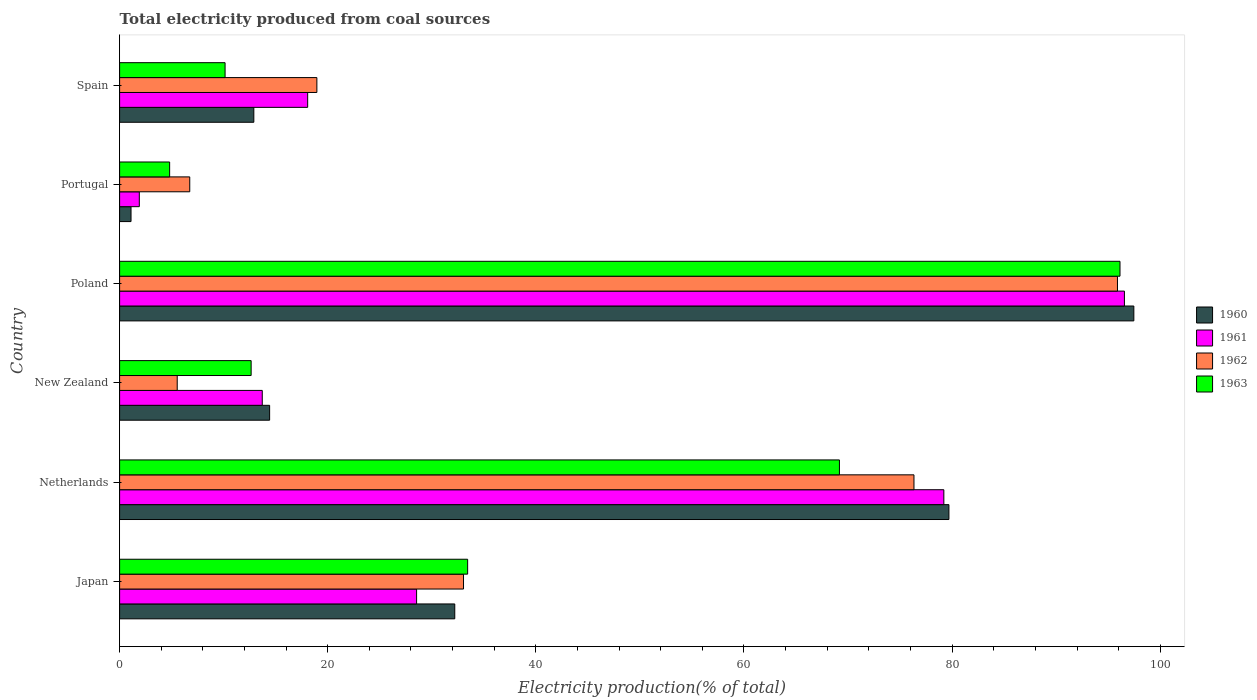How many different coloured bars are there?
Make the answer very short. 4. Are the number of bars on each tick of the Y-axis equal?
Provide a succinct answer. Yes. How many bars are there on the 2nd tick from the bottom?
Ensure brevity in your answer.  4. What is the label of the 4th group of bars from the top?
Ensure brevity in your answer.  New Zealand. In how many cases, is the number of bars for a given country not equal to the number of legend labels?
Your answer should be very brief. 0. What is the total electricity produced in 1962 in New Zealand?
Provide a succinct answer. 5.54. Across all countries, what is the maximum total electricity produced in 1960?
Your response must be concise. 97.46. Across all countries, what is the minimum total electricity produced in 1963?
Your answer should be very brief. 4.81. In which country was the total electricity produced in 1962 maximum?
Your answer should be compact. Poland. In which country was the total electricity produced in 1963 minimum?
Ensure brevity in your answer.  Portugal. What is the total total electricity produced in 1961 in the graph?
Provide a succinct answer. 237.98. What is the difference between the total electricity produced in 1962 in New Zealand and that in Poland?
Offer a very short reply. -90.35. What is the difference between the total electricity produced in 1963 in Japan and the total electricity produced in 1962 in Portugal?
Give a very brief answer. 26.7. What is the average total electricity produced in 1961 per country?
Provide a succinct answer. 39.66. What is the difference between the total electricity produced in 1960 and total electricity produced in 1961 in Poland?
Make the answer very short. 0.91. What is the ratio of the total electricity produced in 1963 in Japan to that in Netherlands?
Make the answer very short. 0.48. Is the total electricity produced in 1963 in Poland less than that in Portugal?
Keep it short and to the point. No. Is the difference between the total electricity produced in 1960 in Japan and Portugal greater than the difference between the total electricity produced in 1961 in Japan and Portugal?
Provide a succinct answer. Yes. What is the difference between the highest and the second highest total electricity produced in 1963?
Your answer should be compact. 26.96. What is the difference between the highest and the lowest total electricity produced in 1961?
Give a very brief answer. 94.66. In how many countries, is the total electricity produced in 1961 greater than the average total electricity produced in 1961 taken over all countries?
Offer a terse response. 2. Is the sum of the total electricity produced in 1962 in Poland and Spain greater than the maximum total electricity produced in 1963 across all countries?
Provide a succinct answer. Yes. How many bars are there?
Offer a very short reply. 24. What is the difference between two consecutive major ticks on the X-axis?
Offer a terse response. 20. Are the values on the major ticks of X-axis written in scientific E-notation?
Keep it short and to the point. No. Does the graph contain any zero values?
Give a very brief answer. No. Does the graph contain grids?
Ensure brevity in your answer.  No. How many legend labels are there?
Offer a very short reply. 4. How are the legend labels stacked?
Your answer should be very brief. Vertical. What is the title of the graph?
Provide a short and direct response. Total electricity produced from coal sources. Does "1997" appear as one of the legend labels in the graph?
Offer a very short reply. No. What is the label or title of the X-axis?
Provide a succinct answer. Electricity production(% of total). What is the label or title of the Y-axis?
Give a very brief answer. Country. What is the Electricity production(% of total) of 1960 in Japan?
Make the answer very short. 32.21. What is the Electricity production(% of total) of 1961 in Japan?
Provide a short and direct response. 28.54. What is the Electricity production(% of total) in 1962 in Japan?
Offer a terse response. 33.05. What is the Electricity production(% of total) in 1963 in Japan?
Your answer should be compact. 33.44. What is the Electricity production(% of total) in 1960 in Netherlands?
Provide a short and direct response. 79.69. What is the Electricity production(% of total) of 1961 in Netherlands?
Provide a succinct answer. 79.2. What is the Electricity production(% of total) in 1962 in Netherlands?
Make the answer very short. 76.33. What is the Electricity production(% of total) in 1963 in Netherlands?
Provide a short and direct response. 69.17. What is the Electricity production(% of total) in 1960 in New Zealand?
Make the answer very short. 14.42. What is the Electricity production(% of total) in 1961 in New Zealand?
Offer a very short reply. 13.71. What is the Electricity production(% of total) of 1962 in New Zealand?
Your response must be concise. 5.54. What is the Electricity production(% of total) of 1963 in New Zealand?
Provide a short and direct response. 12.64. What is the Electricity production(% of total) in 1960 in Poland?
Offer a very short reply. 97.46. What is the Electricity production(% of total) in 1961 in Poland?
Keep it short and to the point. 96.56. What is the Electricity production(% of total) of 1962 in Poland?
Your answer should be very brief. 95.89. What is the Electricity production(% of total) in 1963 in Poland?
Give a very brief answer. 96.13. What is the Electricity production(% of total) of 1960 in Portugal?
Offer a terse response. 1.1. What is the Electricity production(% of total) in 1961 in Portugal?
Ensure brevity in your answer.  1.89. What is the Electricity production(% of total) in 1962 in Portugal?
Provide a succinct answer. 6.74. What is the Electricity production(% of total) of 1963 in Portugal?
Provide a succinct answer. 4.81. What is the Electricity production(% of total) of 1960 in Spain?
Offer a terse response. 12.9. What is the Electricity production(% of total) of 1961 in Spain?
Make the answer very short. 18.07. What is the Electricity production(% of total) of 1962 in Spain?
Make the answer very short. 18.96. What is the Electricity production(% of total) of 1963 in Spain?
Your answer should be very brief. 10.14. Across all countries, what is the maximum Electricity production(% of total) in 1960?
Your response must be concise. 97.46. Across all countries, what is the maximum Electricity production(% of total) in 1961?
Make the answer very short. 96.56. Across all countries, what is the maximum Electricity production(% of total) in 1962?
Your answer should be compact. 95.89. Across all countries, what is the maximum Electricity production(% of total) in 1963?
Offer a terse response. 96.13. Across all countries, what is the minimum Electricity production(% of total) in 1960?
Ensure brevity in your answer.  1.1. Across all countries, what is the minimum Electricity production(% of total) of 1961?
Provide a short and direct response. 1.89. Across all countries, what is the minimum Electricity production(% of total) of 1962?
Your response must be concise. 5.54. Across all countries, what is the minimum Electricity production(% of total) in 1963?
Your answer should be very brief. 4.81. What is the total Electricity production(% of total) of 1960 in the graph?
Keep it short and to the point. 237.78. What is the total Electricity production(% of total) of 1961 in the graph?
Make the answer very short. 237.98. What is the total Electricity production(% of total) of 1962 in the graph?
Offer a terse response. 236.5. What is the total Electricity production(% of total) in 1963 in the graph?
Your answer should be compact. 226.33. What is the difference between the Electricity production(% of total) in 1960 in Japan and that in Netherlands?
Keep it short and to the point. -47.48. What is the difference between the Electricity production(% of total) of 1961 in Japan and that in Netherlands?
Provide a succinct answer. -50.67. What is the difference between the Electricity production(% of total) in 1962 in Japan and that in Netherlands?
Your response must be concise. -43.28. What is the difference between the Electricity production(% of total) in 1963 in Japan and that in Netherlands?
Make the answer very short. -35.73. What is the difference between the Electricity production(% of total) of 1960 in Japan and that in New Zealand?
Your answer should be very brief. 17.79. What is the difference between the Electricity production(% of total) in 1961 in Japan and that in New Zealand?
Offer a very short reply. 14.83. What is the difference between the Electricity production(% of total) of 1962 in Japan and that in New Zealand?
Provide a short and direct response. 27.51. What is the difference between the Electricity production(% of total) in 1963 in Japan and that in New Zealand?
Give a very brief answer. 20.8. What is the difference between the Electricity production(% of total) in 1960 in Japan and that in Poland?
Your answer should be very brief. -65.25. What is the difference between the Electricity production(% of total) in 1961 in Japan and that in Poland?
Keep it short and to the point. -68.02. What is the difference between the Electricity production(% of total) of 1962 in Japan and that in Poland?
Your answer should be very brief. -62.84. What is the difference between the Electricity production(% of total) of 1963 in Japan and that in Poland?
Keep it short and to the point. -62.69. What is the difference between the Electricity production(% of total) of 1960 in Japan and that in Portugal?
Keep it short and to the point. 31.11. What is the difference between the Electricity production(% of total) of 1961 in Japan and that in Portugal?
Offer a terse response. 26.64. What is the difference between the Electricity production(% of total) in 1962 in Japan and that in Portugal?
Your response must be concise. 26.31. What is the difference between the Electricity production(% of total) in 1963 in Japan and that in Portugal?
Your answer should be very brief. 28.63. What is the difference between the Electricity production(% of total) in 1960 in Japan and that in Spain?
Provide a short and direct response. 19.31. What is the difference between the Electricity production(% of total) in 1961 in Japan and that in Spain?
Keep it short and to the point. 10.47. What is the difference between the Electricity production(% of total) in 1962 in Japan and that in Spain?
Your response must be concise. 14.09. What is the difference between the Electricity production(% of total) of 1963 in Japan and that in Spain?
Your answer should be very brief. 23.31. What is the difference between the Electricity production(% of total) of 1960 in Netherlands and that in New Zealand?
Keep it short and to the point. 65.28. What is the difference between the Electricity production(% of total) in 1961 in Netherlands and that in New Zealand?
Ensure brevity in your answer.  65.5. What is the difference between the Electricity production(% of total) in 1962 in Netherlands and that in New Zealand?
Make the answer very short. 70.8. What is the difference between the Electricity production(% of total) in 1963 in Netherlands and that in New Zealand?
Your answer should be very brief. 56.53. What is the difference between the Electricity production(% of total) in 1960 in Netherlands and that in Poland?
Ensure brevity in your answer.  -17.77. What is the difference between the Electricity production(% of total) of 1961 in Netherlands and that in Poland?
Give a very brief answer. -17.35. What is the difference between the Electricity production(% of total) of 1962 in Netherlands and that in Poland?
Give a very brief answer. -19.56. What is the difference between the Electricity production(% of total) of 1963 in Netherlands and that in Poland?
Make the answer very short. -26.96. What is the difference between the Electricity production(% of total) of 1960 in Netherlands and that in Portugal?
Your answer should be very brief. 78.59. What is the difference between the Electricity production(% of total) of 1961 in Netherlands and that in Portugal?
Provide a succinct answer. 77.31. What is the difference between the Electricity production(% of total) in 1962 in Netherlands and that in Portugal?
Ensure brevity in your answer.  69.59. What is the difference between the Electricity production(% of total) of 1963 in Netherlands and that in Portugal?
Your response must be concise. 64.36. What is the difference between the Electricity production(% of total) in 1960 in Netherlands and that in Spain?
Make the answer very short. 66.79. What is the difference between the Electricity production(% of total) of 1961 in Netherlands and that in Spain?
Keep it short and to the point. 61.13. What is the difference between the Electricity production(% of total) in 1962 in Netherlands and that in Spain?
Provide a succinct answer. 57.38. What is the difference between the Electricity production(% of total) of 1963 in Netherlands and that in Spain?
Your answer should be very brief. 59.04. What is the difference between the Electricity production(% of total) in 1960 in New Zealand and that in Poland?
Provide a succinct answer. -83.05. What is the difference between the Electricity production(% of total) in 1961 in New Zealand and that in Poland?
Offer a terse response. -82.85. What is the difference between the Electricity production(% of total) of 1962 in New Zealand and that in Poland?
Your answer should be very brief. -90.35. What is the difference between the Electricity production(% of total) in 1963 in New Zealand and that in Poland?
Give a very brief answer. -83.49. What is the difference between the Electricity production(% of total) in 1960 in New Zealand and that in Portugal?
Provide a short and direct response. 13.32. What is the difference between the Electricity production(% of total) in 1961 in New Zealand and that in Portugal?
Offer a terse response. 11.81. What is the difference between the Electricity production(% of total) of 1962 in New Zealand and that in Portugal?
Make the answer very short. -1.2. What is the difference between the Electricity production(% of total) of 1963 in New Zealand and that in Portugal?
Keep it short and to the point. 7.83. What is the difference between the Electricity production(% of total) of 1960 in New Zealand and that in Spain?
Offer a very short reply. 1.52. What is the difference between the Electricity production(% of total) of 1961 in New Zealand and that in Spain?
Your answer should be very brief. -4.36. What is the difference between the Electricity production(% of total) in 1962 in New Zealand and that in Spain?
Offer a very short reply. -13.42. What is the difference between the Electricity production(% of total) in 1963 in New Zealand and that in Spain?
Keep it short and to the point. 2.5. What is the difference between the Electricity production(% of total) of 1960 in Poland and that in Portugal?
Your response must be concise. 96.36. What is the difference between the Electricity production(% of total) in 1961 in Poland and that in Portugal?
Give a very brief answer. 94.66. What is the difference between the Electricity production(% of total) of 1962 in Poland and that in Portugal?
Provide a succinct answer. 89.15. What is the difference between the Electricity production(% of total) of 1963 in Poland and that in Portugal?
Provide a short and direct response. 91.32. What is the difference between the Electricity production(% of total) of 1960 in Poland and that in Spain?
Your response must be concise. 84.56. What is the difference between the Electricity production(% of total) of 1961 in Poland and that in Spain?
Provide a short and direct response. 78.49. What is the difference between the Electricity production(% of total) of 1962 in Poland and that in Spain?
Your response must be concise. 76.93. What is the difference between the Electricity production(% of total) in 1963 in Poland and that in Spain?
Provide a succinct answer. 86. What is the difference between the Electricity production(% of total) in 1960 in Portugal and that in Spain?
Offer a terse response. -11.8. What is the difference between the Electricity production(% of total) of 1961 in Portugal and that in Spain?
Offer a very short reply. -16.18. What is the difference between the Electricity production(% of total) of 1962 in Portugal and that in Spain?
Your answer should be very brief. -12.22. What is the difference between the Electricity production(% of total) of 1963 in Portugal and that in Spain?
Keep it short and to the point. -5.33. What is the difference between the Electricity production(% of total) in 1960 in Japan and the Electricity production(% of total) in 1961 in Netherlands?
Make the answer very short. -47. What is the difference between the Electricity production(% of total) in 1960 in Japan and the Electricity production(% of total) in 1962 in Netherlands?
Provide a short and direct response. -44.13. What is the difference between the Electricity production(% of total) of 1960 in Japan and the Electricity production(% of total) of 1963 in Netherlands?
Keep it short and to the point. -36.96. What is the difference between the Electricity production(% of total) in 1961 in Japan and the Electricity production(% of total) in 1962 in Netherlands?
Ensure brevity in your answer.  -47.79. What is the difference between the Electricity production(% of total) in 1961 in Japan and the Electricity production(% of total) in 1963 in Netherlands?
Give a very brief answer. -40.63. What is the difference between the Electricity production(% of total) of 1962 in Japan and the Electricity production(% of total) of 1963 in Netherlands?
Keep it short and to the point. -36.12. What is the difference between the Electricity production(% of total) in 1960 in Japan and the Electricity production(% of total) in 1961 in New Zealand?
Ensure brevity in your answer.  18.5. What is the difference between the Electricity production(% of total) in 1960 in Japan and the Electricity production(% of total) in 1962 in New Zealand?
Keep it short and to the point. 26.67. What is the difference between the Electricity production(% of total) in 1960 in Japan and the Electricity production(% of total) in 1963 in New Zealand?
Provide a short and direct response. 19.57. What is the difference between the Electricity production(% of total) of 1961 in Japan and the Electricity production(% of total) of 1962 in New Zealand?
Make the answer very short. 23. What is the difference between the Electricity production(% of total) in 1961 in Japan and the Electricity production(% of total) in 1963 in New Zealand?
Ensure brevity in your answer.  15.9. What is the difference between the Electricity production(% of total) of 1962 in Japan and the Electricity production(% of total) of 1963 in New Zealand?
Your answer should be compact. 20.41. What is the difference between the Electricity production(% of total) of 1960 in Japan and the Electricity production(% of total) of 1961 in Poland?
Offer a very short reply. -64.35. What is the difference between the Electricity production(% of total) in 1960 in Japan and the Electricity production(% of total) in 1962 in Poland?
Provide a succinct answer. -63.68. What is the difference between the Electricity production(% of total) of 1960 in Japan and the Electricity production(% of total) of 1963 in Poland?
Provide a succinct answer. -63.92. What is the difference between the Electricity production(% of total) of 1961 in Japan and the Electricity production(% of total) of 1962 in Poland?
Offer a very short reply. -67.35. What is the difference between the Electricity production(% of total) in 1961 in Japan and the Electricity production(% of total) in 1963 in Poland?
Keep it short and to the point. -67.59. What is the difference between the Electricity production(% of total) in 1962 in Japan and the Electricity production(% of total) in 1963 in Poland?
Ensure brevity in your answer.  -63.08. What is the difference between the Electricity production(% of total) of 1960 in Japan and the Electricity production(% of total) of 1961 in Portugal?
Provide a short and direct response. 30.31. What is the difference between the Electricity production(% of total) in 1960 in Japan and the Electricity production(% of total) in 1962 in Portugal?
Provide a succinct answer. 25.47. What is the difference between the Electricity production(% of total) in 1960 in Japan and the Electricity production(% of total) in 1963 in Portugal?
Offer a very short reply. 27.4. What is the difference between the Electricity production(% of total) of 1961 in Japan and the Electricity production(% of total) of 1962 in Portugal?
Your answer should be very brief. 21.8. What is the difference between the Electricity production(% of total) of 1961 in Japan and the Electricity production(% of total) of 1963 in Portugal?
Give a very brief answer. 23.73. What is the difference between the Electricity production(% of total) in 1962 in Japan and the Electricity production(% of total) in 1963 in Portugal?
Keep it short and to the point. 28.24. What is the difference between the Electricity production(% of total) in 1960 in Japan and the Electricity production(% of total) in 1961 in Spain?
Offer a terse response. 14.14. What is the difference between the Electricity production(% of total) of 1960 in Japan and the Electricity production(% of total) of 1962 in Spain?
Your response must be concise. 13.25. What is the difference between the Electricity production(% of total) in 1960 in Japan and the Electricity production(% of total) in 1963 in Spain?
Offer a terse response. 22.07. What is the difference between the Electricity production(% of total) of 1961 in Japan and the Electricity production(% of total) of 1962 in Spain?
Keep it short and to the point. 9.58. What is the difference between the Electricity production(% of total) in 1961 in Japan and the Electricity production(% of total) in 1963 in Spain?
Provide a short and direct response. 18.4. What is the difference between the Electricity production(% of total) of 1962 in Japan and the Electricity production(% of total) of 1963 in Spain?
Your answer should be very brief. 22.91. What is the difference between the Electricity production(% of total) in 1960 in Netherlands and the Electricity production(% of total) in 1961 in New Zealand?
Give a very brief answer. 65.98. What is the difference between the Electricity production(% of total) of 1960 in Netherlands and the Electricity production(% of total) of 1962 in New Zealand?
Your answer should be very brief. 74.16. What is the difference between the Electricity production(% of total) in 1960 in Netherlands and the Electricity production(% of total) in 1963 in New Zealand?
Keep it short and to the point. 67.05. What is the difference between the Electricity production(% of total) in 1961 in Netherlands and the Electricity production(% of total) in 1962 in New Zealand?
Provide a succinct answer. 73.67. What is the difference between the Electricity production(% of total) of 1961 in Netherlands and the Electricity production(% of total) of 1963 in New Zealand?
Your answer should be compact. 66.56. What is the difference between the Electricity production(% of total) in 1962 in Netherlands and the Electricity production(% of total) in 1963 in New Zealand?
Make the answer very short. 63.69. What is the difference between the Electricity production(% of total) in 1960 in Netherlands and the Electricity production(% of total) in 1961 in Poland?
Make the answer very short. -16.86. What is the difference between the Electricity production(% of total) of 1960 in Netherlands and the Electricity production(% of total) of 1962 in Poland?
Provide a succinct answer. -16.2. What is the difference between the Electricity production(% of total) in 1960 in Netherlands and the Electricity production(% of total) in 1963 in Poland?
Offer a very short reply. -16.44. What is the difference between the Electricity production(% of total) in 1961 in Netherlands and the Electricity production(% of total) in 1962 in Poland?
Your response must be concise. -16.68. What is the difference between the Electricity production(% of total) in 1961 in Netherlands and the Electricity production(% of total) in 1963 in Poland?
Your answer should be very brief. -16.93. What is the difference between the Electricity production(% of total) in 1962 in Netherlands and the Electricity production(% of total) in 1963 in Poland?
Your answer should be very brief. -19.8. What is the difference between the Electricity production(% of total) of 1960 in Netherlands and the Electricity production(% of total) of 1961 in Portugal?
Give a very brief answer. 77.8. What is the difference between the Electricity production(% of total) in 1960 in Netherlands and the Electricity production(% of total) in 1962 in Portugal?
Keep it short and to the point. 72.95. What is the difference between the Electricity production(% of total) in 1960 in Netherlands and the Electricity production(% of total) in 1963 in Portugal?
Ensure brevity in your answer.  74.88. What is the difference between the Electricity production(% of total) of 1961 in Netherlands and the Electricity production(% of total) of 1962 in Portugal?
Make the answer very short. 72.46. What is the difference between the Electricity production(% of total) in 1961 in Netherlands and the Electricity production(% of total) in 1963 in Portugal?
Keep it short and to the point. 74.4. What is the difference between the Electricity production(% of total) in 1962 in Netherlands and the Electricity production(% of total) in 1963 in Portugal?
Provide a short and direct response. 71.52. What is the difference between the Electricity production(% of total) of 1960 in Netherlands and the Electricity production(% of total) of 1961 in Spain?
Your answer should be very brief. 61.62. What is the difference between the Electricity production(% of total) in 1960 in Netherlands and the Electricity production(% of total) in 1962 in Spain?
Your answer should be very brief. 60.74. What is the difference between the Electricity production(% of total) in 1960 in Netherlands and the Electricity production(% of total) in 1963 in Spain?
Provide a short and direct response. 69.56. What is the difference between the Electricity production(% of total) in 1961 in Netherlands and the Electricity production(% of total) in 1962 in Spain?
Give a very brief answer. 60.25. What is the difference between the Electricity production(% of total) in 1961 in Netherlands and the Electricity production(% of total) in 1963 in Spain?
Your answer should be compact. 69.07. What is the difference between the Electricity production(% of total) of 1962 in Netherlands and the Electricity production(% of total) of 1963 in Spain?
Offer a terse response. 66.2. What is the difference between the Electricity production(% of total) of 1960 in New Zealand and the Electricity production(% of total) of 1961 in Poland?
Give a very brief answer. -82.14. What is the difference between the Electricity production(% of total) in 1960 in New Zealand and the Electricity production(% of total) in 1962 in Poland?
Make the answer very short. -81.47. What is the difference between the Electricity production(% of total) in 1960 in New Zealand and the Electricity production(% of total) in 1963 in Poland?
Provide a short and direct response. -81.71. What is the difference between the Electricity production(% of total) in 1961 in New Zealand and the Electricity production(% of total) in 1962 in Poland?
Your response must be concise. -82.18. What is the difference between the Electricity production(% of total) in 1961 in New Zealand and the Electricity production(% of total) in 1963 in Poland?
Keep it short and to the point. -82.42. What is the difference between the Electricity production(% of total) in 1962 in New Zealand and the Electricity production(% of total) in 1963 in Poland?
Provide a succinct answer. -90.6. What is the difference between the Electricity production(% of total) in 1960 in New Zealand and the Electricity production(% of total) in 1961 in Portugal?
Ensure brevity in your answer.  12.52. What is the difference between the Electricity production(% of total) in 1960 in New Zealand and the Electricity production(% of total) in 1962 in Portugal?
Ensure brevity in your answer.  7.68. What is the difference between the Electricity production(% of total) of 1960 in New Zealand and the Electricity production(% of total) of 1963 in Portugal?
Offer a terse response. 9.61. What is the difference between the Electricity production(% of total) in 1961 in New Zealand and the Electricity production(% of total) in 1962 in Portugal?
Offer a terse response. 6.97. What is the difference between the Electricity production(% of total) of 1961 in New Zealand and the Electricity production(% of total) of 1963 in Portugal?
Provide a short and direct response. 8.9. What is the difference between the Electricity production(% of total) of 1962 in New Zealand and the Electricity production(% of total) of 1963 in Portugal?
Provide a succinct answer. 0.73. What is the difference between the Electricity production(% of total) of 1960 in New Zealand and the Electricity production(% of total) of 1961 in Spain?
Your answer should be compact. -3.65. What is the difference between the Electricity production(% of total) of 1960 in New Zealand and the Electricity production(% of total) of 1962 in Spain?
Make the answer very short. -4.54. What is the difference between the Electricity production(% of total) of 1960 in New Zealand and the Electricity production(% of total) of 1963 in Spain?
Your answer should be compact. 4.28. What is the difference between the Electricity production(% of total) of 1961 in New Zealand and the Electricity production(% of total) of 1962 in Spain?
Keep it short and to the point. -5.25. What is the difference between the Electricity production(% of total) of 1961 in New Zealand and the Electricity production(% of total) of 1963 in Spain?
Offer a very short reply. 3.57. What is the difference between the Electricity production(% of total) of 1962 in New Zealand and the Electricity production(% of total) of 1963 in Spain?
Provide a succinct answer. -4.6. What is the difference between the Electricity production(% of total) in 1960 in Poland and the Electricity production(% of total) in 1961 in Portugal?
Your answer should be very brief. 95.57. What is the difference between the Electricity production(% of total) of 1960 in Poland and the Electricity production(% of total) of 1962 in Portugal?
Your answer should be very brief. 90.72. What is the difference between the Electricity production(% of total) of 1960 in Poland and the Electricity production(% of total) of 1963 in Portugal?
Your answer should be compact. 92.65. What is the difference between the Electricity production(% of total) of 1961 in Poland and the Electricity production(% of total) of 1962 in Portugal?
Provide a succinct answer. 89.82. What is the difference between the Electricity production(% of total) of 1961 in Poland and the Electricity production(% of total) of 1963 in Portugal?
Your response must be concise. 91.75. What is the difference between the Electricity production(% of total) of 1962 in Poland and the Electricity production(% of total) of 1963 in Portugal?
Offer a terse response. 91.08. What is the difference between the Electricity production(% of total) of 1960 in Poland and the Electricity production(% of total) of 1961 in Spain?
Provide a succinct answer. 79.39. What is the difference between the Electricity production(% of total) of 1960 in Poland and the Electricity production(% of total) of 1962 in Spain?
Provide a short and direct response. 78.51. What is the difference between the Electricity production(% of total) of 1960 in Poland and the Electricity production(% of total) of 1963 in Spain?
Ensure brevity in your answer.  87.33. What is the difference between the Electricity production(% of total) of 1961 in Poland and the Electricity production(% of total) of 1962 in Spain?
Make the answer very short. 77.6. What is the difference between the Electricity production(% of total) of 1961 in Poland and the Electricity production(% of total) of 1963 in Spain?
Offer a very short reply. 86.42. What is the difference between the Electricity production(% of total) in 1962 in Poland and the Electricity production(% of total) in 1963 in Spain?
Provide a short and direct response. 85.75. What is the difference between the Electricity production(% of total) of 1960 in Portugal and the Electricity production(% of total) of 1961 in Spain?
Make the answer very short. -16.97. What is the difference between the Electricity production(% of total) in 1960 in Portugal and the Electricity production(% of total) in 1962 in Spain?
Ensure brevity in your answer.  -17.86. What is the difference between the Electricity production(% of total) in 1960 in Portugal and the Electricity production(% of total) in 1963 in Spain?
Offer a very short reply. -9.04. What is the difference between the Electricity production(% of total) of 1961 in Portugal and the Electricity production(% of total) of 1962 in Spain?
Keep it short and to the point. -17.06. What is the difference between the Electricity production(% of total) in 1961 in Portugal and the Electricity production(% of total) in 1963 in Spain?
Offer a terse response. -8.24. What is the difference between the Electricity production(% of total) in 1962 in Portugal and the Electricity production(% of total) in 1963 in Spain?
Make the answer very short. -3.4. What is the average Electricity production(% of total) of 1960 per country?
Provide a short and direct response. 39.63. What is the average Electricity production(% of total) in 1961 per country?
Your answer should be very brief. 39.66. What is the average Electricity production(% of total) in 1962 per country?
Make the answer very short. 39.42. What is the average Electricity production(% of total) in 1963 per country?
Offer a terse response. 37.72. What is the difference between the Electricity production(% of total) in 1960 and Electricity production(% of total) in 1961 in Japan?
Ensure brevity in your answer.  3.67. What is the difference between the Electricity production(% of total) of 1960 and Electricity production(% of total) of 1962 in Japan?
Offer a terse response. -0.84. What is the difference between the Electricity production(% of total) of 1960 and Electricity production(% of total) of 1963 in Japan?
Give a very brief answer. -1.24. What is the difference between the Electricity production(% of total) in 1961 and Electricity production(% of total) in 1962 in Japan?
Your response must be concise. -4.51. What is the difference between the Electricity production(% of total) of 1961 and Electricity production(% of total) of 1963 in Japan?
Keep it short and to the point. -4.9. What is the difference between the Electricity production(% of total) in 1962 and Electricity production(% of total) in 1963 in Japan?
Keep it short and to the point. -0.4. What is the difference between the Electricity production(% of total) in 1960 and Electricity production(% of total) in 1961 in Netherlands?
Provide a succinct answer. 0.49. What is the difference between the Electricity production(% of total) in 1960 and Electricity production(% of total) in 1962 in Netherlands?
Offer a terse response. 3.36. What is the difference between the Electricity production(% of total) in 1960 and Electricity production(% of total) in 1963 in Netherlands?
Your answer should be very brief. 10.52. What is the difference between the Electricity production(% of total) in 1961 and Electricity production(% of total) in 1962 in Netherlands?
Provide a short and direct response. 2.87. What is the difference between the Electricity production(% of total) in 1961 and Electricity production(% of total) in 1963 in Netherlands?
Your response must be concise. 10.03. What is the difference between the Electricity production(% of total) of 1962 and Electricity production(% of total) of 1963 in Netherlands?
Keep it short and to the point. 7.16. What is the difference between the Electricity production(% of total) in 1960 and Electricity production(% of total) in 1961 in New Zealand?
Keep it short and to the point. 0.71. What is the difference between the Electricity production(% of total) of 1960 and Electricity production(% of total) of 1962 in New Zealand?
Make the answer very short. 8.88. What is the difference between the Electricity production(% of total) in 1960 and Electricity production(% of total) in 1963 in New Zealand?
Give a very brief answer. 1.78. What is the difference between the Electricity production(% of total) of 1961 and Electricity production(% of total) of 1962 in New Zealand?
Your answer should be very brief. 8.17. What is the difference between the Electricity production(% of total) of 1961 and Electricity production(% of total) of 1963 in New Zealand?
Make the answer very short. 1.07. What is the difference between the Electricity production(% of total) in 1962 and Electricity production(% of total) in 1963 in New Zealand?
Make the answer very short. -7.1. What is the difference between the Electricity production(% of total) in 1960 and Electricity production(% of total) in 1961 in Poland?
Provide a short and direct response. 0.91. What is the difference between the Electricity production(% of total) of 1960 and Electricity production(% of total) of 1962 in Poland?
Give a very brief answer. 1.57. What is the difference between the Electricity production(% of total) in 1960 and Electricity production(% of total) in 1963 in Poland?
Provide a short and direct response. 1.33. What is the difference between the Electricity production(% of total) of 1961 and Electricity production(% of total) of 1962 in Poland?
Your response must be concise. 0.67. What is the difference between the Electricity production(% of total) of 1961 and Electricity production(% of total) of 1963 in Poland?
Provide a short and direct response. 0.43. What is the difference between the Electricity production(% of total) of 1962 and Electricity production(% of total) of 1963 in Poland?
Offer a very short reply. -0.24. What is the difference between the Electricity production(% of total) of 1960 and Electricity production(% of total) of 1961 in Portugal?
Offer a terse response. -0.8. What is the difference between the Electricity production(% of total) in 1960 and Electricity production(% of total) in 1962 in Portugal?
Your response must be concise. -5.64. What is the difference between the Electricity production(% of total) in 1960 and Electricity production(% of total) in 1963 in Portugal?
Offer a terse response. -3.71. What is the difference between the Electricity production(% of total) in 1961 and Electricity production(% of total) in 1962 in Portugal?
Give a very brief answer. -4.85. What is the difference between the Electricity production(% of total) in 1961 and Electricity production(% of total) in 1963 in Portugal?
Give a very brief answer. -2.91. What is the difference between the Electricity production(% of total) of 1962 and Electricity production(% of total) of 1963 in Portugal?
Make the answer very short. 1.93. What is the difference between the Electricity production(% of total) of 1960 and Electricity production(% of total) of 1961 in Spain?
Offer a very short reply. -5.17. What is the difference between the Electricity production(% of total) of 1960 and Electricity production(% of total) of 1962 in Spain?
Offer a very short reply. -6.06. What is the difference between the Electricity production(% of total) of 1960 and Electricity production(% of total) of 1963 in Spain?
Provide a succinct answer. 2.76. What is the difference between the Electricity production(% of total) in 1961 and Electricity production(% of total) in 1962 in Spain?
Provide a succinct answer. -0.88. What is the difference between the Electricity production(% of total) of 1961 and Electricity production(% of total) of 1963 in Spain?
Give a very brief answer. 7.94. What is the difference between the Electricity production(% of total) in 1962 and Electricity production(% of total) in 1963 in Spain?
Ensure brevity in your answer.  8.82. What is the ratio of the Electricity production(% of total) of 1960 in Japan to that in Netherlands?
Provide a succinct answer. 0.4. What is the ratio of the Electricity production(% of total) in 1961 in Japan to that in Netherlands?
Your answer should be compact. 0.36. What is the ratio of the Electricity production(% of total) of 1962 in Japan to that in Netherlands?
Make the answer very short. 0.43. What is the ratio of the Electricity production(% of total) in 1963 in Japan to that in Netherlands?
Offer a very short reply. 0.48. What is the ratio of the Electricity production(% of total) in 1960 in Japan to that in New Zealand?
Provide a succinct answer. 2.23. What is the ratio of the Electricity production(% of total) of 1961 in Japan to that in New Zealand?
Ensure brevity in your answer.  2.08. What is the ratio of the Electricity production(% of total) of 1962 in Japan to that in New Zealand?
Keep it short and to the point. 5.97. What is the ratio of the Electricity production(% of total) of 1963 in Japan to that in New Zealand?
Make the answer very short. 2.65. What is the ratio of the Electricity production(% of total) in 1960 in Japan to that in Poland?
Keep it short and to the point. 0.33. What is the ratio of the Electricity production(% of total) in 1961 in Japan to that in Poland?
Offer a terse response. 0.3. What is the ratio of the Electricity production(% of total) in 1962 in Japan to that in Poland?
Your answer should be compact. 0.34. What is the ratio of the Electricity production(% of total) in 1963 in Japan to that in Poland?
Offer a terse response. 0.35. What is the ratio of the Electricity production(% of total) in 1960 in Japan to that in Portugal?
Make the answer very short. 29.34. What is the ratio of the Electricity production(% of total) of 1961 in Japan to that in Portugal?
Your response must be concise. 15.06. What is the ratio of the Electricity production(% of total) of 1962 in Japan to that in Portugal?
Offer a terse response. 4.9. What is the ratio of the Electricity production(% of total) in 1963 in Japan to that in Portugal?
Provide a short and direct response. 6.95. What is the ratio of the Electricity production(% of total) of 1960 in Japan to that in Spain?
Offer a terse response. 2.5. What is the ratio of the Electricity production(% of total) in 1961 in Japan to that in Spain?
Keep it short and to the point. 1.58. What is the ratio of the Electricity production(% of total) in 1962 in Japan to that in Spain?
Your answer should be compact. 1.74. What is the ratio of the Electricity production(% of total) in 1963 in Japan to that in Spain?
Offer a terse response. 3.3. What is the ratio of the Electricity production(% of total) in 1960 in Netherlands to that in New Zealand?
Provide a short and direct response. 5.53. What is the ratio of the Electricity production(% of total) in 1961 in Netherlands to that in New Zealand?
Offer a terse response. 5.78. What is the ratio of the Electricity production(% of total) of 1962 in Netherlands to that in New Zealand?
Give a very brief answer. 13.79. What is the ratio of the Electricity production(% of total) of 1963 in Netherlands to that in New Zealand?
Provide a short and direct response. 5.47. What is the ratio of the Electricity production(% of total) in 1960 in Netherlands to that in Poland?
Offer a terse response. 0.82. What is the ratio of the Electricity production(% of total) of 1961 in Netherlands to that in Poland?
Provide a short and direct response. 0.82. What is the ratio of the Electricity production(% of total) of 1962 in Netherlands to that in Poland?
Ensure brevity in your answer.  0.8. What is the ratio of the Electricity production(% of total) of 1963 in Netherlands to that in Poland?
Make the answer very short. 0.72. What is the ratio of the Electricity production(% of total) of 1960 in Netherlands to that in Portugal?
Provide a succinct answer. 72.59. What is the ratio of the Electricity production(% of total) in 1961 in Netherlands to that in Portugal?
Provide a short and direct response. 41.81. What is the ratio of the Electricity production(% of total) of 1962 in Netherlands to that in Portugal?
Keep it short and to the point. 11.32. What is the ratio of the Electricity production(% of total) of 1963 in Netherlands to that in Portugal?
Offer a very short reply. 14.38. What is the ratio of the Electricity production(% of total) of 1960 in Netherlands to that in Spain?
Offer a very short reply. 6.18. What is the ratio of the Electricity production(% of total) in 1961 in Netherlands to that in Spain?
Keep it short and to the point. 4.38. What is the ratio of the Electricity production(% of total) in 1962 in Netherlands to that in Spain?
Make the answer very short. 4.03. What is the ratio of the Electricity production(% of total) in 1963 in Netherlands to that in Spain?
Your answer should be compact. 6.82. What is the ratio of the Electricity production(% of total) of 1960 in New Zealand to that in Poland?
Provide a succinct answer. 0.15. What is the ratio of the Electricity production(% of total) in 1961 in New Zealand to that in Poland?
Your answer should be very brief. 0.14. What is the ratio of the Electricity production(% of total) of 1962 in New Zealand to that in Poland?
Your response must be concise. 0.06. What is the ratio of the Electricity production(% of total) in 1963 in New Zealand to that in Poland?
Make the answer very short. 0.13. What is the ratio of the Electricity production(% of total) in 1960 in New Zealand to that in Portugal?
Make the answer very short. 13.13. What is the ratio of the Electricity production(% of total) in 1961 in New Zealand to that in Portugal?
Give a very brief answer. 7.24. What is the ratio of the Electricity production(% of total) of 1962 in New Zealand to that in Portugal?
Keep it short and to the point. 0.82. What is the ratio of the Electricity production(% of total) of 1963 in New Zealand to that in Portugal?
Your answer should be compact. 2.63. What is the ratio of the Electricity production(% of total) of 1960 in New Zealand to that in Spain?
Your response must be concise. 1.12. What is the ratio of the Electricity production(% of total) of 1961 in New Zealand to that in Spain?
Your answer should be compact. 0.76. What is the ratio of the Electricity production(% of total) in 1962 in New Zealand to that in Spain?
Make the answer very short. 0.29. What is the ratio of the Electricity production(% of total) in 1963 in New Zealand to that in Spain?
Your response must be concise. 1.25. What is the ratio of the Electricity production(% of total) of 1960 in Poland to that in Portugal?
Provide a short and direct response. 88.77. What is the ratio of the Electricity production(% of total) in 1961 in Poland to that in Portugal?
Your answer should be compact. 50.97. What is the ratio of the Electricity production(% of total) in 1962 in Poland to that in Portugal?
Give a very brief answer. 14.23. What is the ratio of the Electricity production(% of total) in 1963 in Poland to that in Portugal?
Ensure brevity in your answer.  19.99. What is the ratio of the Electricity production(% of total) of 1960 in Poland to that in Spain?
Your answer should be compact. 7.56. What is the ratio of the Electricity production(% of total) of 1961 in Poland to that in Spain?
Give a very brief answer. 5.34. What is the ratio of the Electricity production(% of total) in 1962 in Poland to that in Spain?
Provide a short and direct response. 5.06. What is the ratio of the Electricity production(% of total) in 1963 in Poland to that in Spain?
Your answer should be compact. 9.48. What is the ratio of the Electricity production(% of total) in 1960 in Portugal to that in Spain?
Your answer should be compact. 0.09. What is the ratio of the Electricity production(% of total) of 1961 in Portugal to that in Spain?
Your answer should be very brief. 0.1. What is the ratio of the Electricity production(% of total) of 1962 in Portugal to that in Spain?
Your answer should be very brief. 0.36. What is the ratio of the Electricity production(% of total) of 1963 in Portugal to that in Spain?
Your response must be concise. 0.47. What is the difference between the highest and the second highest Electricity production(% of total) of 1960?
Provide a succinct answer. 17.77. What is the difference between the highest and the second highest Electricity production(% of total) in 1961?
Your answer should be very brief. 17.35. What is the difference between the highest and the second highest Electricity production(% of total) of 1962?
Your response must be concise. 19.56. What is the difference between the highest and the second highest Electricity production(% of total) in 1963?
Give a very brief answer. 26.96. What is the difference between the highest and the lowest Electricity production(% of total) in 1960?
Make the answer very short. 96.36. What is the difference between the highest and the lowest Electricity production(% of total) of 1961?
Make the answer very short. 94.66. What is the difference between the highest and the lowest Electricity production(% of total) of 1962?
Give a very brief answer. 90.35. What is the difference between the highest and the lowest Electricity production(% of total) of 1963?
Give a very brief answer. 91.32. 